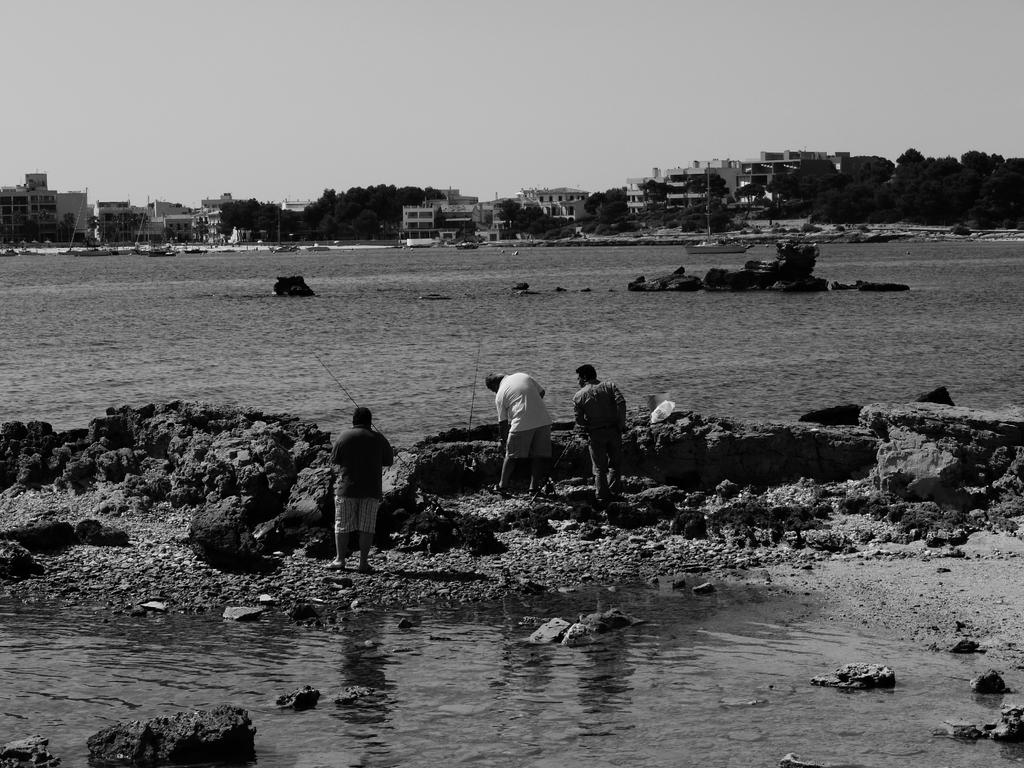What is the color scheme of the image? The image is black and white. What can be seen in the image besides people? There is water visible in the image. What is visible in the background of the image? Trees and buildings are present in the background of the image. What is the purpose of the family's flight in the image? There is no mention of a family or flight in the image, so it is not possible to determine the purpose of any flight. 